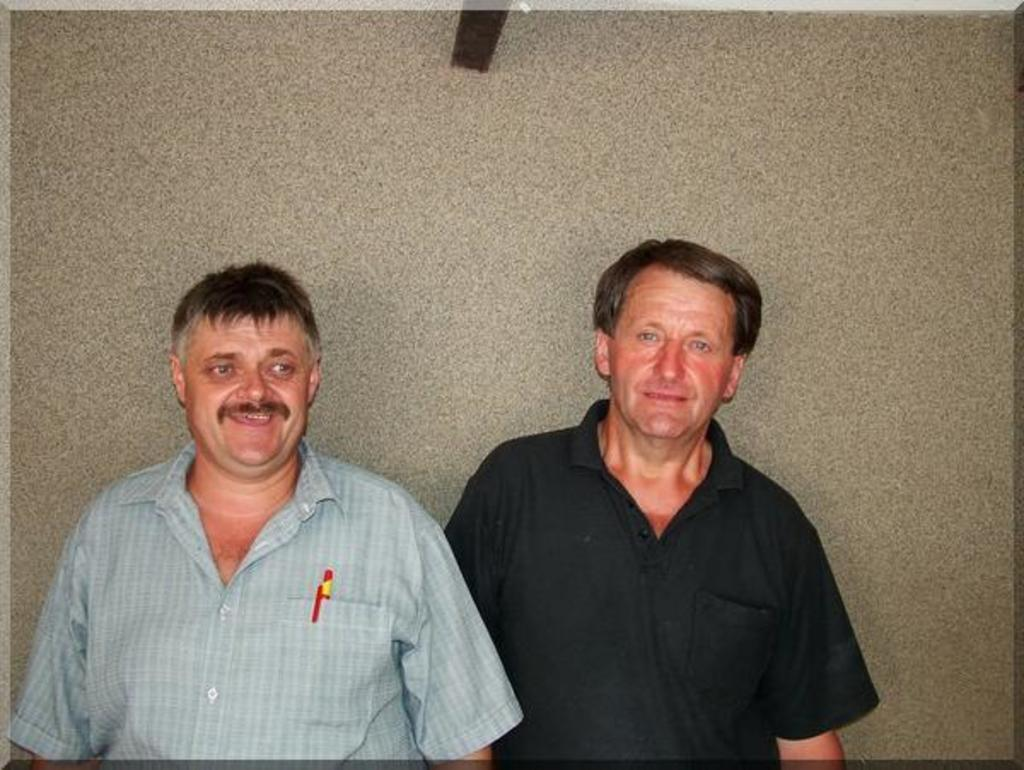How many people are in the image? There are two men in the image. What expressions do the men have? Both men are smiling in the image. Can you describe the clothing of the man on the right side? The man on the right side is wearing a black T-shirt. What type of nut is the cow eating in the image? There is no cow or nut present in the image; it features two men who are both smiling. Why is the man on the left side crying in the image? The man on the left side is not crying in the image; both men are smiling. 